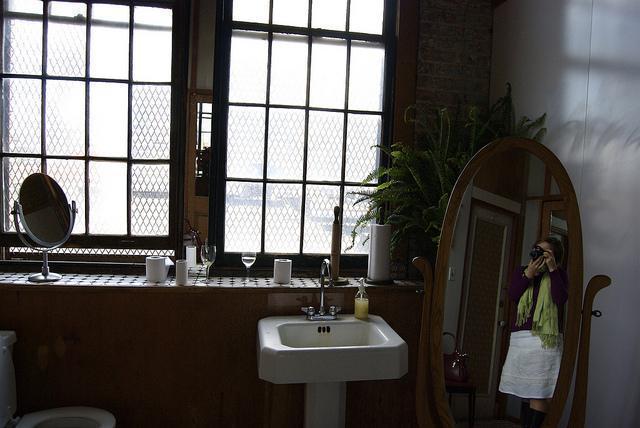Which feature of the camera poses harm to the person taking a photograph of a mirror?
Make your selection from the four choices given to correctly answer the question.
Options: Selfie stick, sounds, flash, dark mode. Flash. 